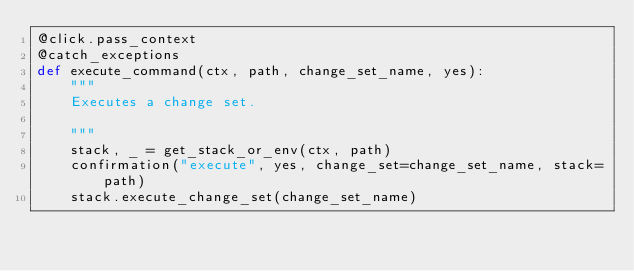<code> <loc_0><loc_0><loc_500><loc_500><_Python_>@click.pass_context
@catch_exceptions
def execute_command(ctx, path, change_set_name, yes):
    """
    Executes a change set.

    """
    stack, _ = get_stack_or_env(ctx, path)
    confirmation("execute", yes, change_set=change_set_name, stack=path)
    stack.execute_change_set(change_set_name)
</code> 